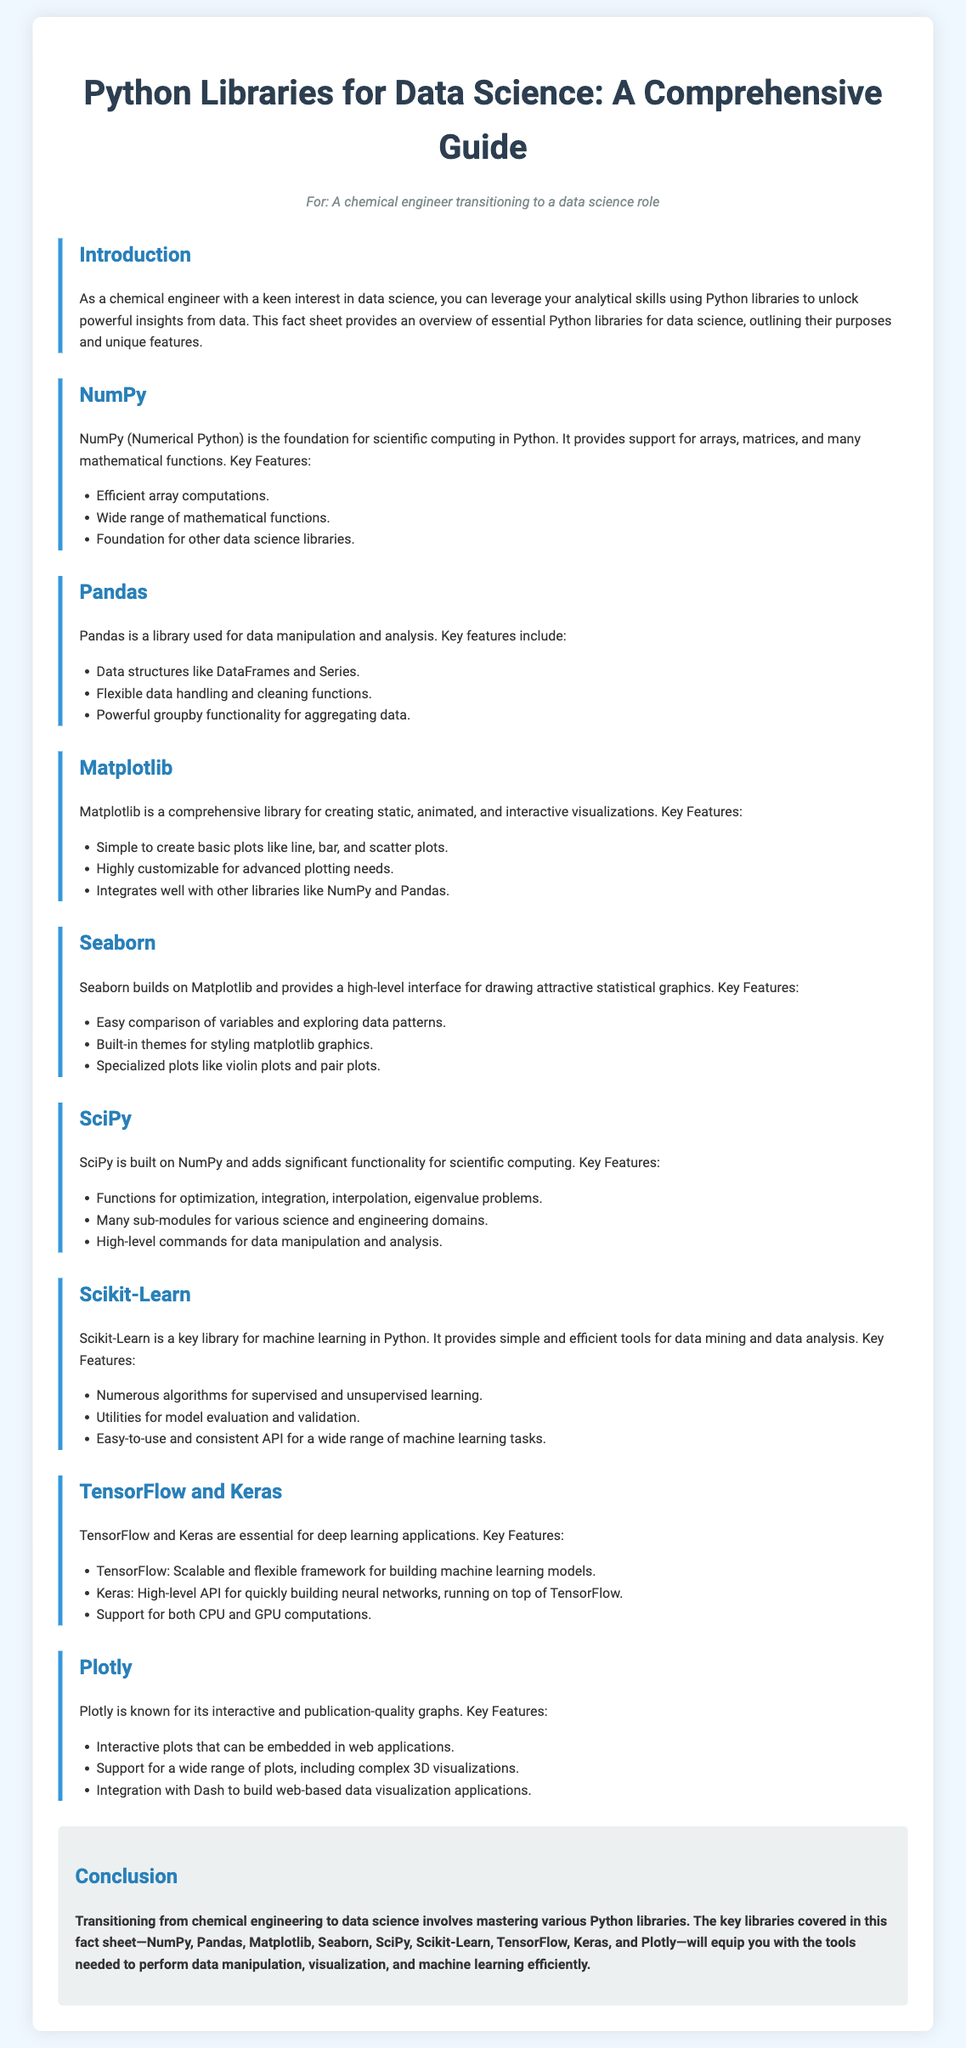What is the main purpose of NumPy? The main purpose of NumPy is to provide support for arrays, matrices, and many mathematical functions.
Answer: support for arrays, matrices, and many mathematical functions What features are included in Pandas? Pandas includes data structures like DataFrames and Series, flexible data handling and cleaning functions, and powerful groupby functionality for aggregating data.
Answer: DataFrames and Series, flexible data handling and cleaning functions, powerful groupby functionality What type of plots can Matplotlib create? Matplotlib can create static, animated, and interactive visualizations, including line, bar, and scatter plots.
Answer: static, animated, and interactive visualizations What is Scikit-Learn primarily used for? Scikit-Learn is primarily used for machine learning in Python.
Answer: machine learning Which library builds on top of Matplotlib? Seaborn builds on top of Matplotlib.
Answer: Seaborn What is the application of TensorFlow and Keras? TensorFlow and Keras are essential for deep learning applications.
Answer: deep learning applications What does Plotly specialize in? Plotly specializes in interactive and publication-quality graphs.
Answer: interactive and publication-quality graphs How many key libraries are mentioned in the conclusion? The conclusion mentions eight key libraries.
Answer: eight 